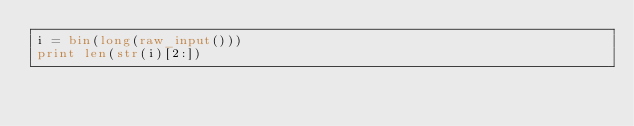Convert code to text. <code><loc_0><loc_0><loc_500><loc_500><_Python_>i = bin(long(raw_input()))
print len(str(i)[2:])</code> 